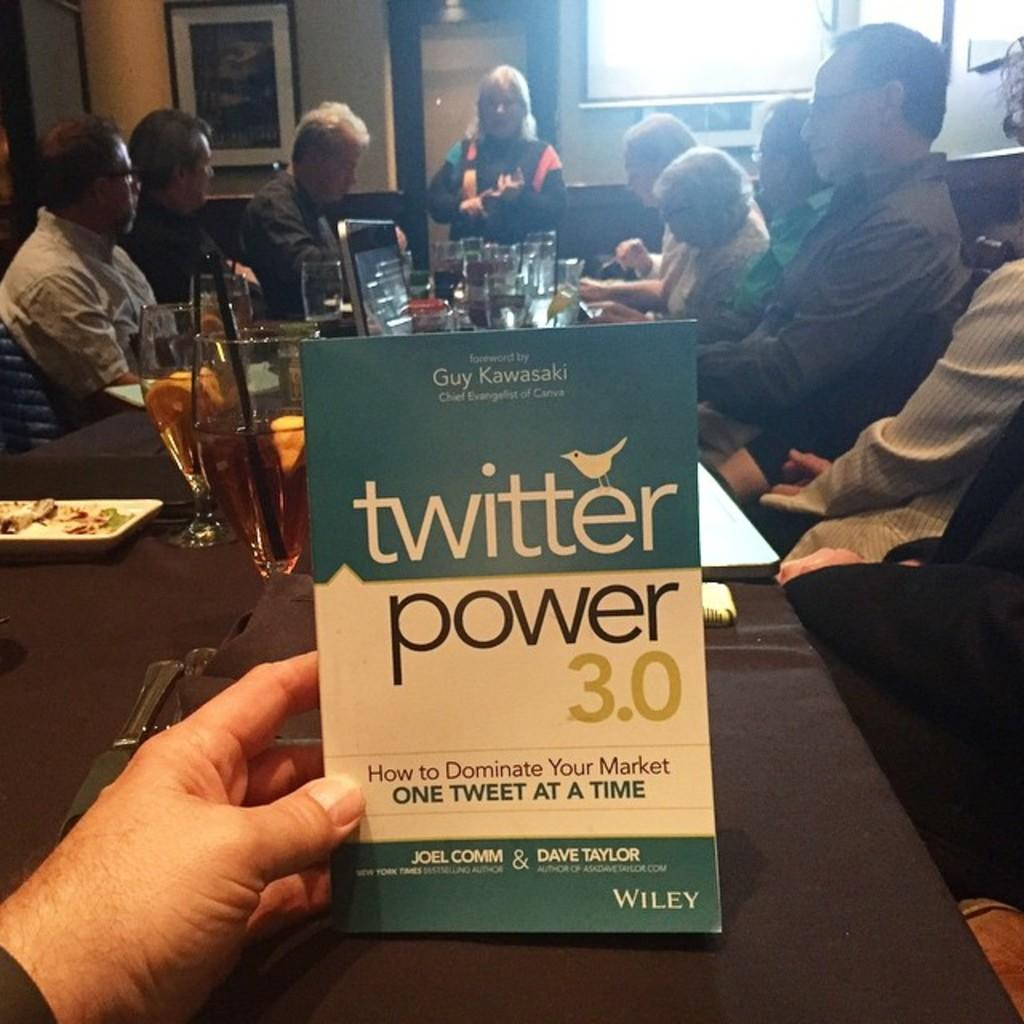<image>
Summarize the visual content of the image. A book labeled Twitter Power 3.0 is held in someones hand. 